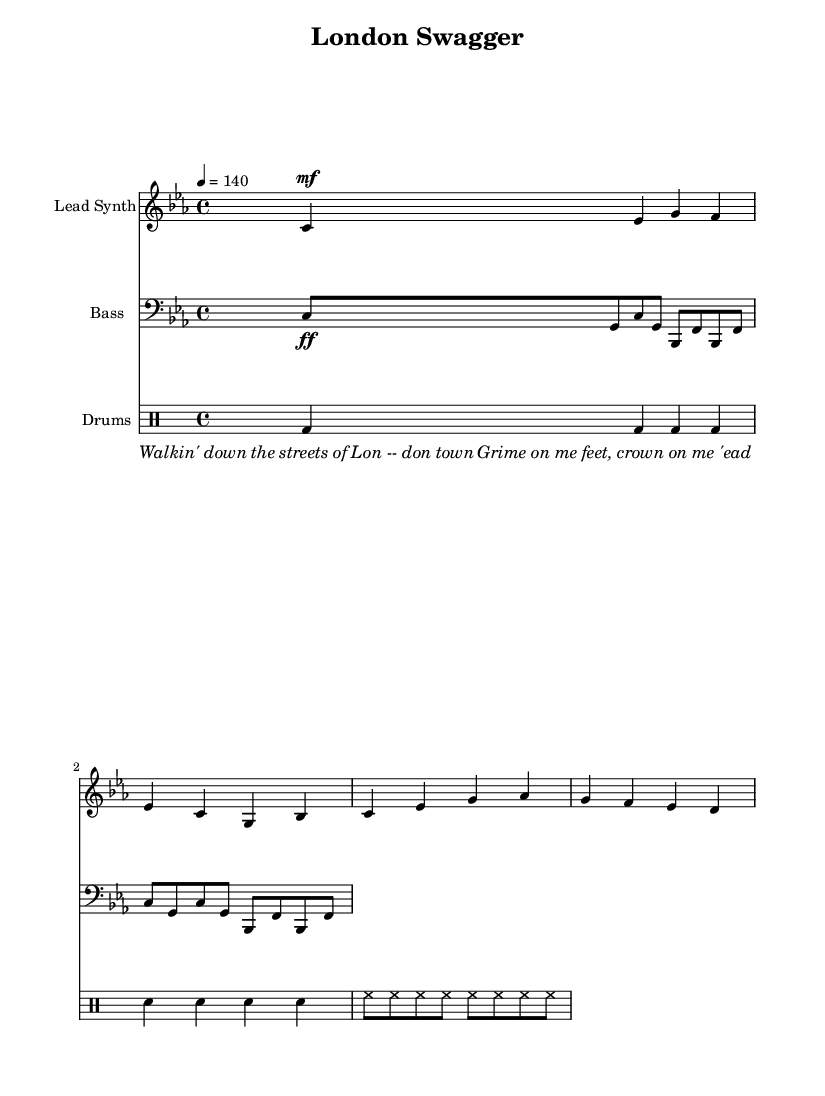What is the key signature of this music? The key signature is C minor, which has three flats (B flat, E flat, A flat). The key is indicated at the beginning of the score.
Answer: C minor What is the time signature of this piece? The time signature is 4/4, which means there are four beats in each measure, and the quarter note gets one beat. This is indicated at the beginning of the score.
Answer: 4/4 What is the tempo marking for this music? The tempo marking is set at 140 beats per minute, which indicates a moderate to fast tempo. This is explicitly stated in the global settings of the score.
Answer: 140 How many measures are there in the lead synth part? The lead synth part contains a total of 4 measures as each section is separated clearly and there are 4 sets of notes.
Answer: 4 What is the instrumentation used in this piece? The instrumentation includes lead synth, bass, and drums, which can be identified by the instrument names specified in the score's staff settings.
Answer: Lead Synth, Bass, Drums What type of lyrics is present in this music? The lyrics are written in a rap style, reflecting London's urban culture and British slang, as indicated by their content and rhythm.
Answer: Rap What is the dynamic marking for the bass part? The dynamic marking for the bass part is ff, which stands for fortissimo, indicating a very loud volume. This is noted in the bass part's instructions.
Answer: ff 